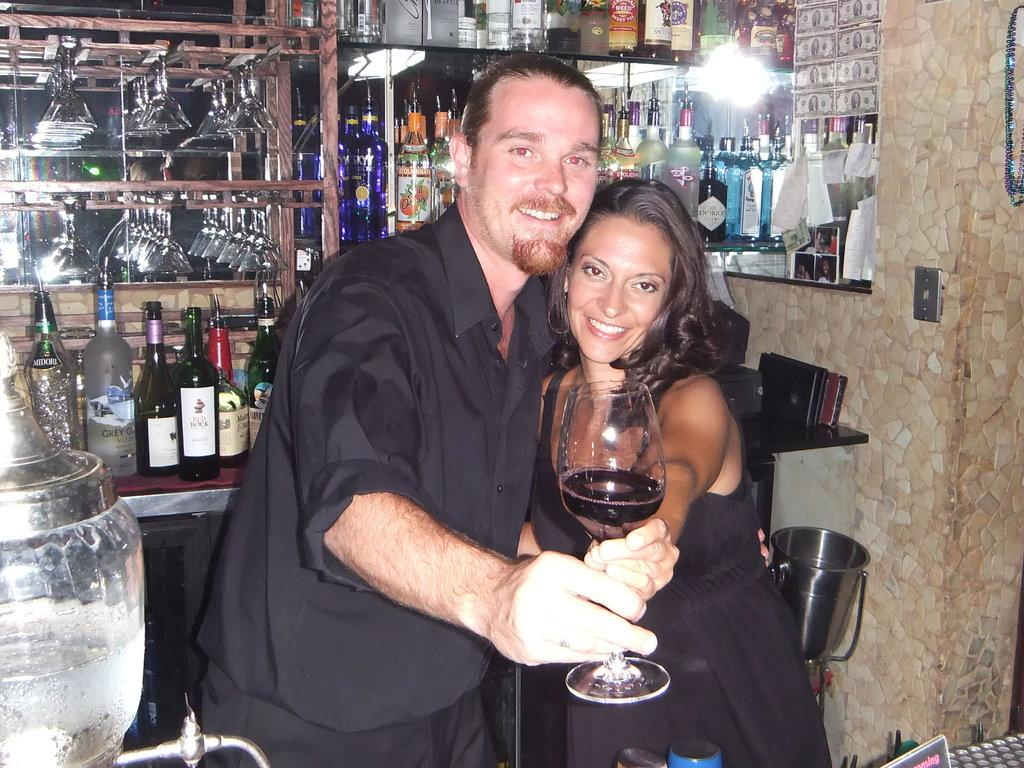How many people are in the image? There are two people in the image. Can you describe the individuals in the image? One of the people is a man, and the other person is a woman. What are they holding in the image? They are holding a glass with wine. Are there any other objects visible in the image? Yes, there are bottles visible in the image. What type of lamp is on the table next to the people in the image? There is no lamp present in the image; it only features two people holding a glass with wine and some bottles. 